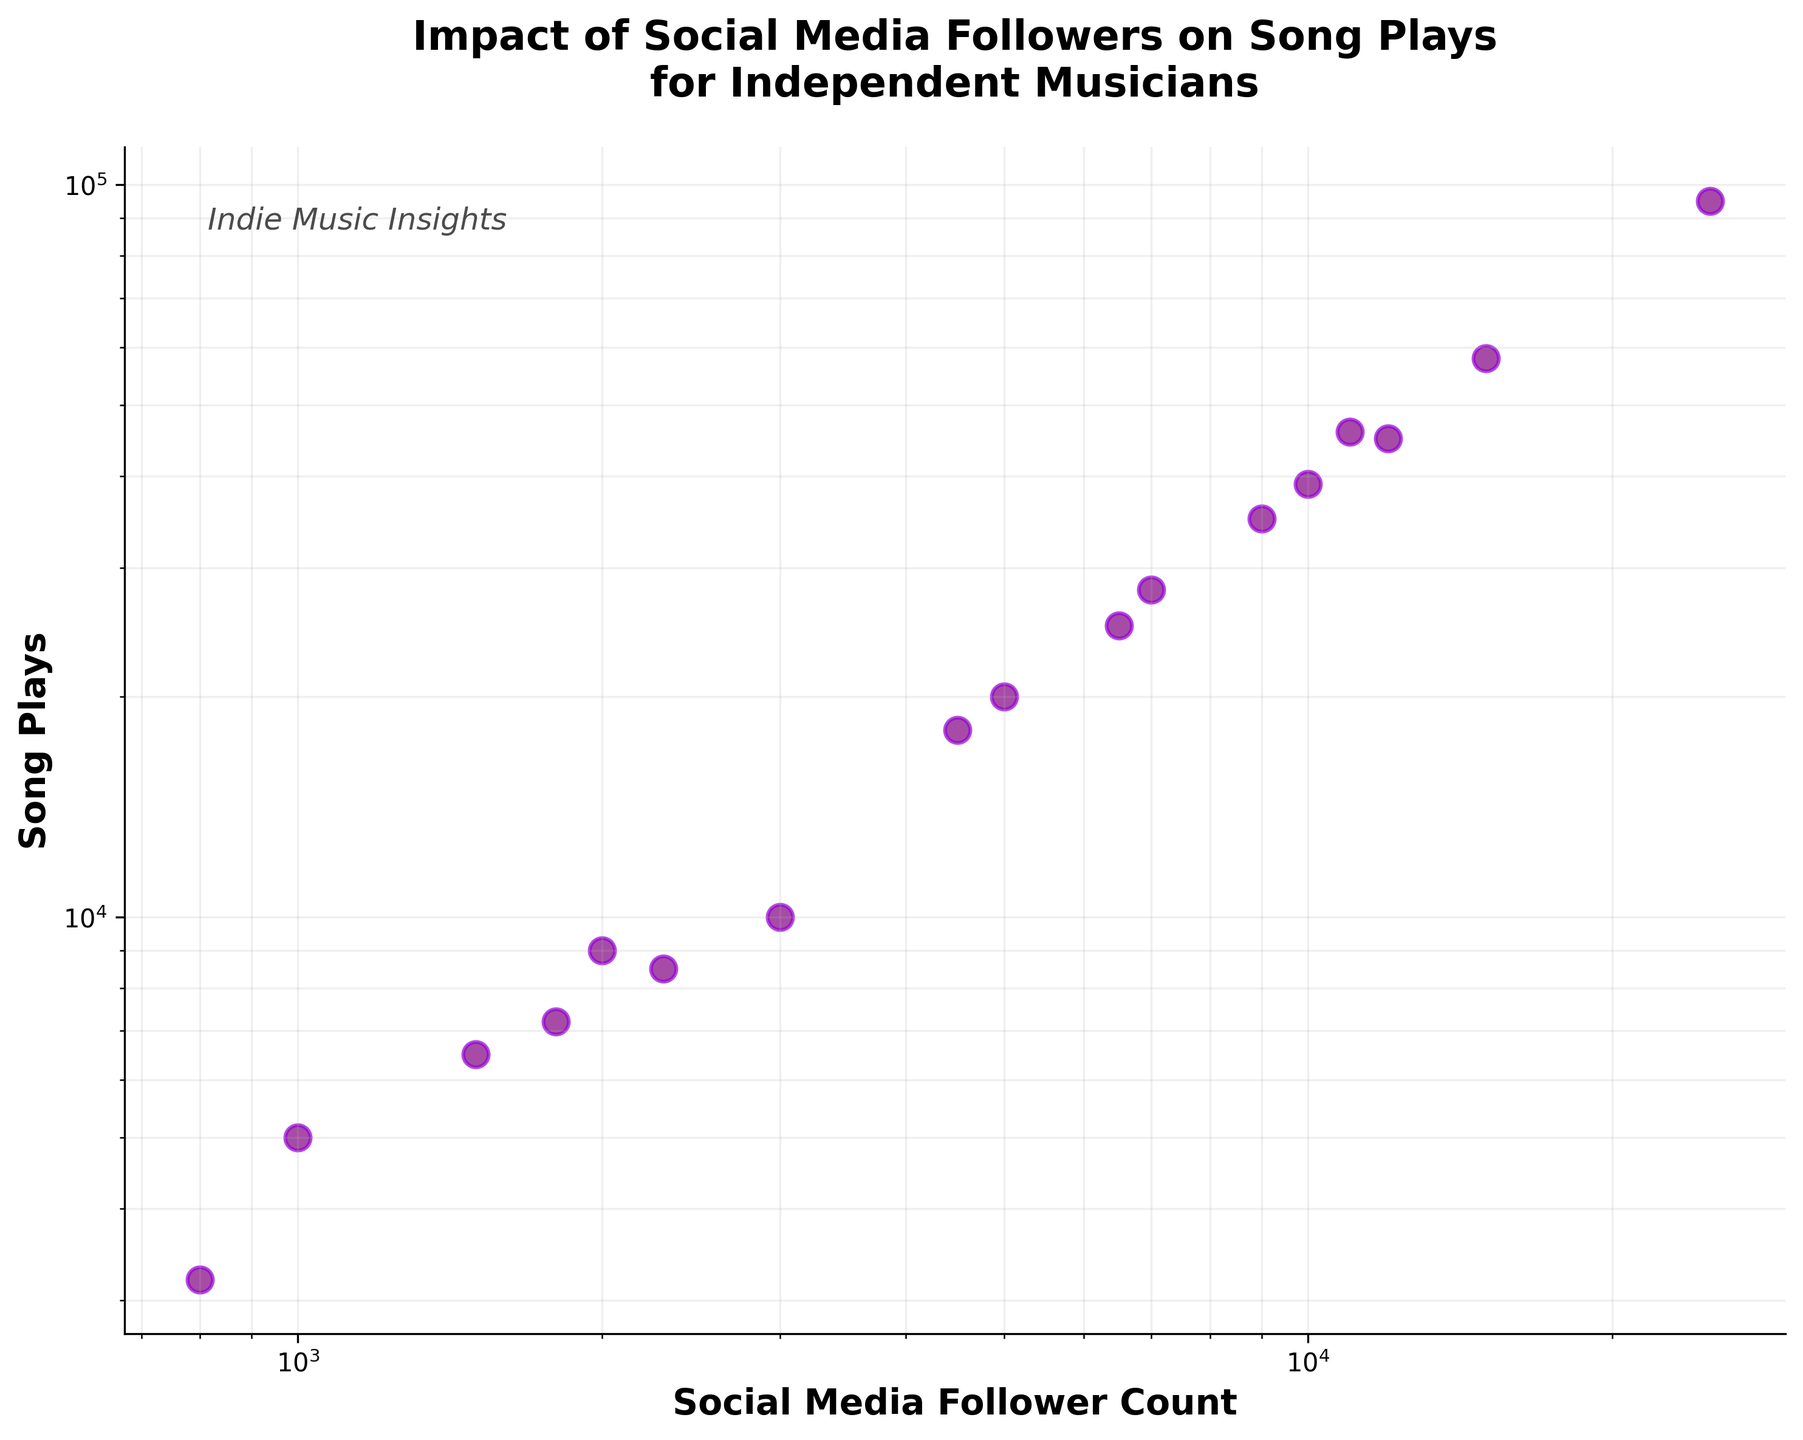How many data points are there in the figure? By visually counting the number of distinct scatter points depicted in the plot, you can determine the number of data points. The scatter plot shows a total of 17 data points.
Answer: 17 What are the labels of the x and y axes? The x-axis label is visible on the horizontal axis, and it indicates 'Social Media Follower Count.' The y-axis label is visible on the vertical axis, indicating 'Song Plays.'
Answer: Social Media Follower Count and Song Plays What is the title of the figure? The title of the figure is prominently displayed at the top and reads 'Impact of Social Media Followers on Song Plays for Independent Musicians.'
Answer: Impact of Social Media Followers on Song Plays for Independent Musicians Which data point represents the highest song plays, and what is its follower count? By examining the vertical axis and looking up to the point with the highest song plays (95,000), you can trace the corresponding value on the horizontal axis to find the follower count, which is 25,000.
Answer: 25,000 followers What is the color used for the data points in the scatter plot? The data points are uniformly colored in a shade of purple. This color scheme is evident from the visual appearance of the scatter points.
Answer: purple How does the song play count change as follower counts increase? Observing the trend from left to right while considering both log scales, there is a general upward trend, indicating that as the follower count increases, the song play count also increases.
Answer: increases Which data point represents the lowest follower count, and how many song plays does it have? By finding the leftmost data point, which represents 800 followers, you can trace upwards to determine the corresponding song plays, which is 3,200.
Answer: 3,200 song plays Which has more song plays, the data point with 5,000 followers or 4,500 followers? By identifying these data points on the plot and comparing their vertical positions, the 5,000 followers data point has 20,000 song plays, whereas the 4,500 followers data point has 18,000 song plays. Thus, the former is higher.
Answer: 5,000 followers What is the average song plays for followers counts of 1,000, 2,000, and 3,000? Extracting these points and calculating their averages: (5,000 + 9,000 + 10,000) / 3 = 24,000 / 3. The average song plays for these follower counts is 8,000.
Answer: 8,000 song plays How many data points have follower counts greater than 10,000? Visually identifying and counting all data points beyond 10,000 followers on the x-axis, there are 4 data points that meet this criterion.
Answer: 4 